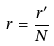<formula> <loc_0><loc_0><loc_500><loc_500>r = \frac { r ^ { \prime } } { N }</formula> 